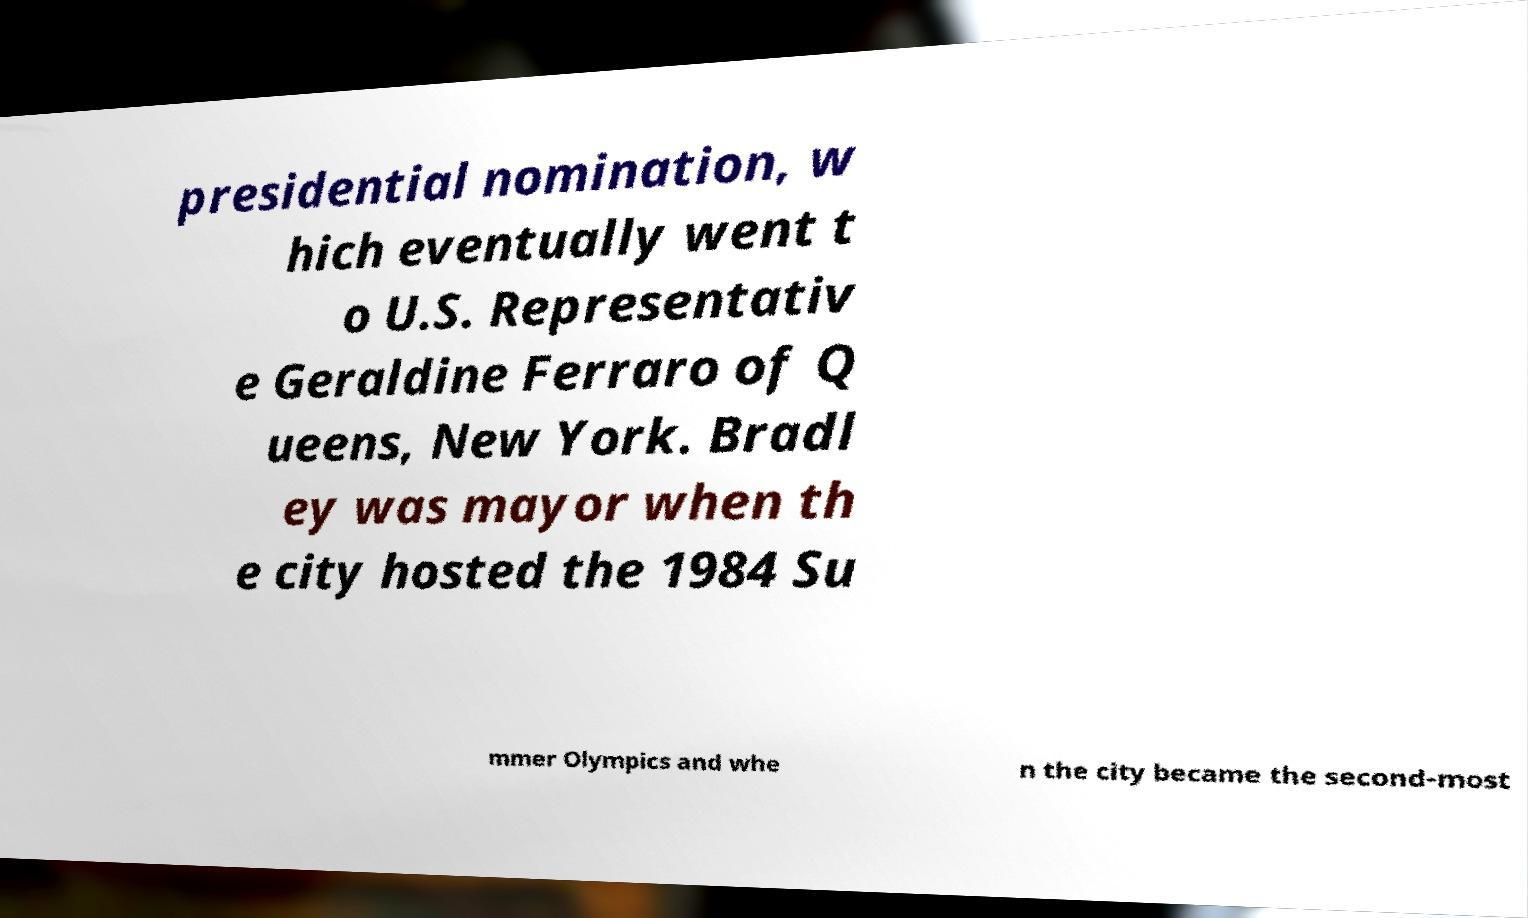I need the written content from this picture converted into text. Can you do that? presidential nomination, w hich eventually went t o U.S. Representativ e Geraldine Ferraro of Q ueens, New York. Bradl ey was mayor when th e city hosted the 1984 Su mmer Olympics and whe n the city became the second-most 